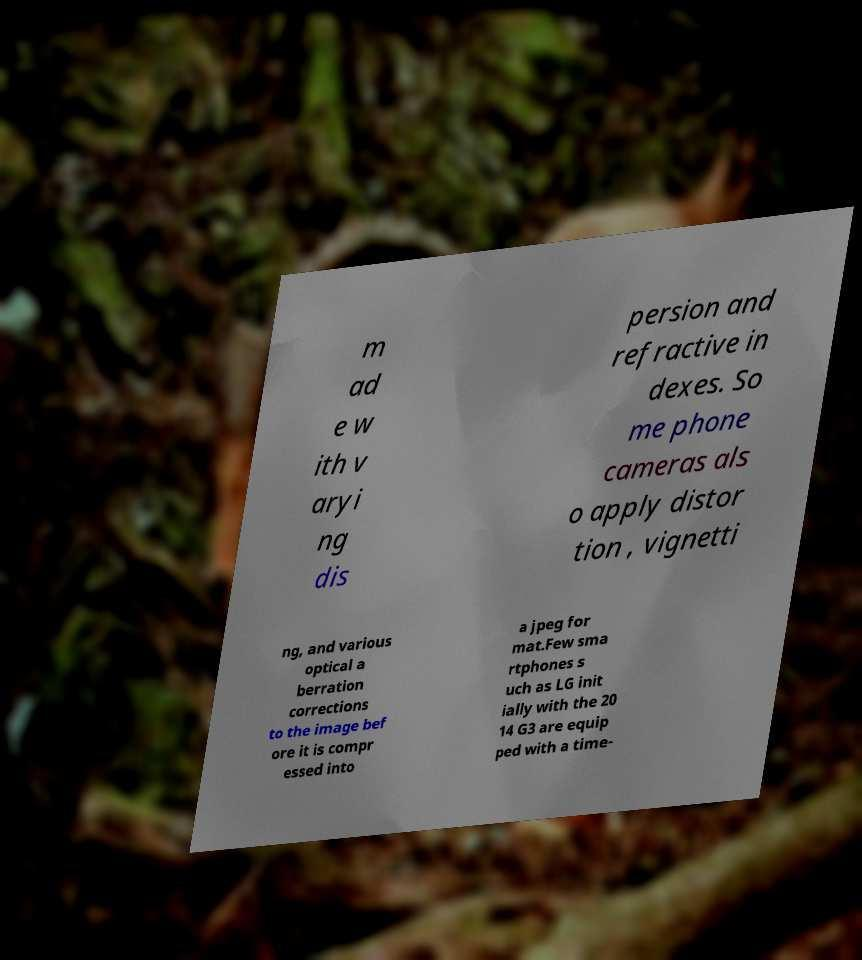There's text embedded in this image that I need extracted. Can you transcribe it verbatim? m ad e w ith v aryi ng dis persion and refractive in dexes. So me phone cameras als o apply distor tion , vignetti ng, and various optical a berration corrections to the image bef ore it is compr essed into a jpeg for mat.Few sma rtphones s uch as LG init ially with the 20 14 G3 are equip ped with a time- 